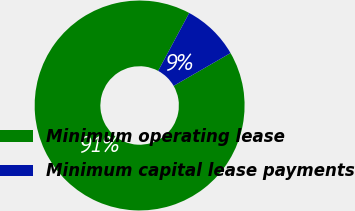<chart> <loc_0><loc_0><loc_500><loc_500><pie_chart><fcel>Minimum operating lease<fcel>Minimum capital lease payments<nl><fcel>91.16%<fcel>8.84%<nl></chart> 